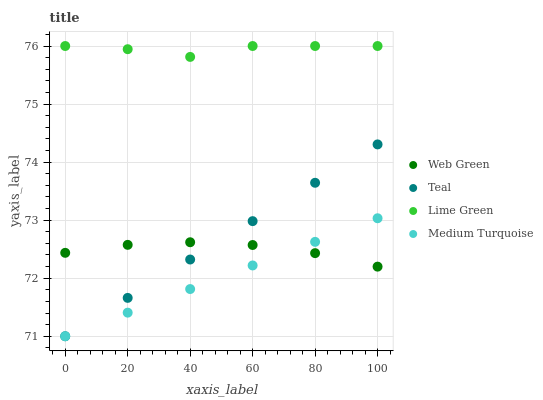Does Medium Turquoise have the minimum area under the curve?
Answer yes or no. Yes. Does Lime Green have the maximum area under the curve?
Answer yes or no. Yes. Does Teal have the minimum area under the curve?
Answer yes or no. No. Does Teal have the maximum area under the curve?
Answer yes or no. No. Is Teal the smoothest?
Answer yes or no. Yes. Is Lime Green the roughest?
Answer yes or no. Yes. Is Lime Green the smoothest?
Answer yes or no. No. Is Teal the roughest?
Answer yes or no. No. Does Medium Turquoise have the lowest value?
Answer yes or no. Yes. Does Lime Green have the lowest value?
Answer yes or no. No. Does Lime Green have the highest value?
Answer yes or no. Yes. Does Teal have the highest value?
Answer yes or no. No. Is Medium Turquoise less than Lime Green?
Answer yes or no. Yes. Is Lime Green greater than Web Green?
Answer yes or no. Yes. Does Medium Turquoise intersect Teal?
Answer yes or no. Yes. Is Medium Turquoise less than Teal?
Answer yes or no. No. Is Medium Turquoise greater than Teal?
Answer yes or no. No. Does Medium Turquoise intersect Lime Green?
Answer yes or no. No. 